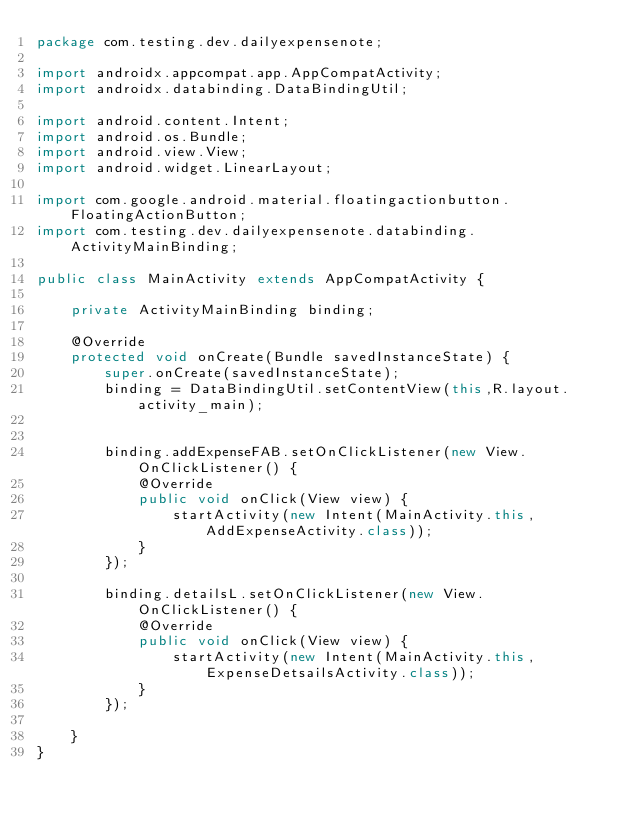<code> <loc_0><loc_0><loc_500><loc_500><_Java_>package com.testing.dev.dailyexpensenote;

import androidx.appcompat.app.AppCompatActivity;
import androidx.databinding.DataBindingUtil;

import android.content.Intent;
import android.os.Bundle;
import android.view.View;
import android.widget.LinearLayout;

import com.google.android.material.floatingactionbutton.FloatingActionButton;
import com.testing.dev.dailyexpensenote.databinding.ActivityMainBinding;

public class MainActivity extends AppCompatActivity {

    private ActivityMainBinding binding;

    @Override
    protected void onCreate(Bundle savedInstanceState) {
        super.onCreate(savedInstanceState);
        binding = DataBindingUtil.setContentView(this,R.layout.activity_main);


        binding.addExpenseFAB.setOnClickListener(new View.OnClickListener() {
            @Override
            public void onClick(View view) {
                startActivity(new Intent(MainActivity.this,AddExpenseActivity.class));
            }
        });

        binding.detailsL.setOnClickListener(new View.OnClickListener() {
            @Override
            public void onClick(View view) {
                startActivity(new Intent(MainActivity.this,ExpenseDetsailsActivity.class));
            }
        });

    }
}
</code> 